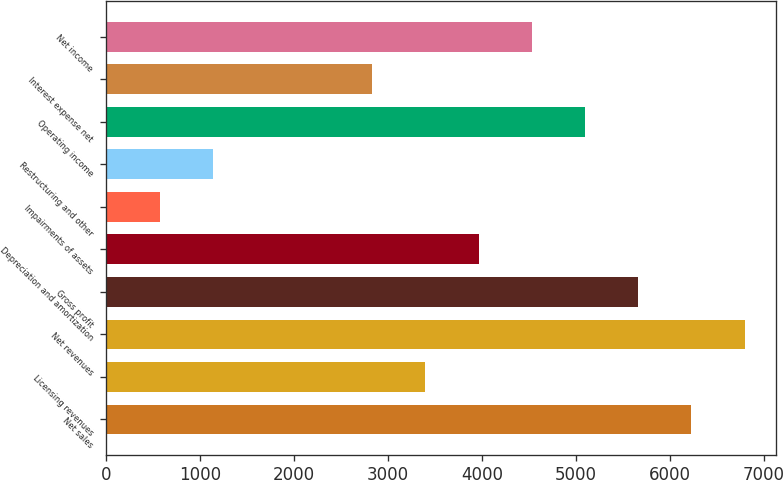Convert chart to OTSL. <chart><loc_0><loc_0><loc_500><loc_500><bar_chart><fcel>Net sales<fcel>Licensing revenues<fcel>Net revenues<fcel>Gross profit<fcel>Depreciation and amortization<fcel>Impairments of assets<fcel>Restructuring and other<fcel>Operating income<fcel>Interest expense net<fcel>Net income<nl><fcel>6225.95<fcel>3396.2<fcel>6791.9<fcel>5660<fcel>3962.15<fcel>566.45<fcel>1132.4<fcel>5094.05<fcel>2830.25<fcel>4528.1<nl></chart> 